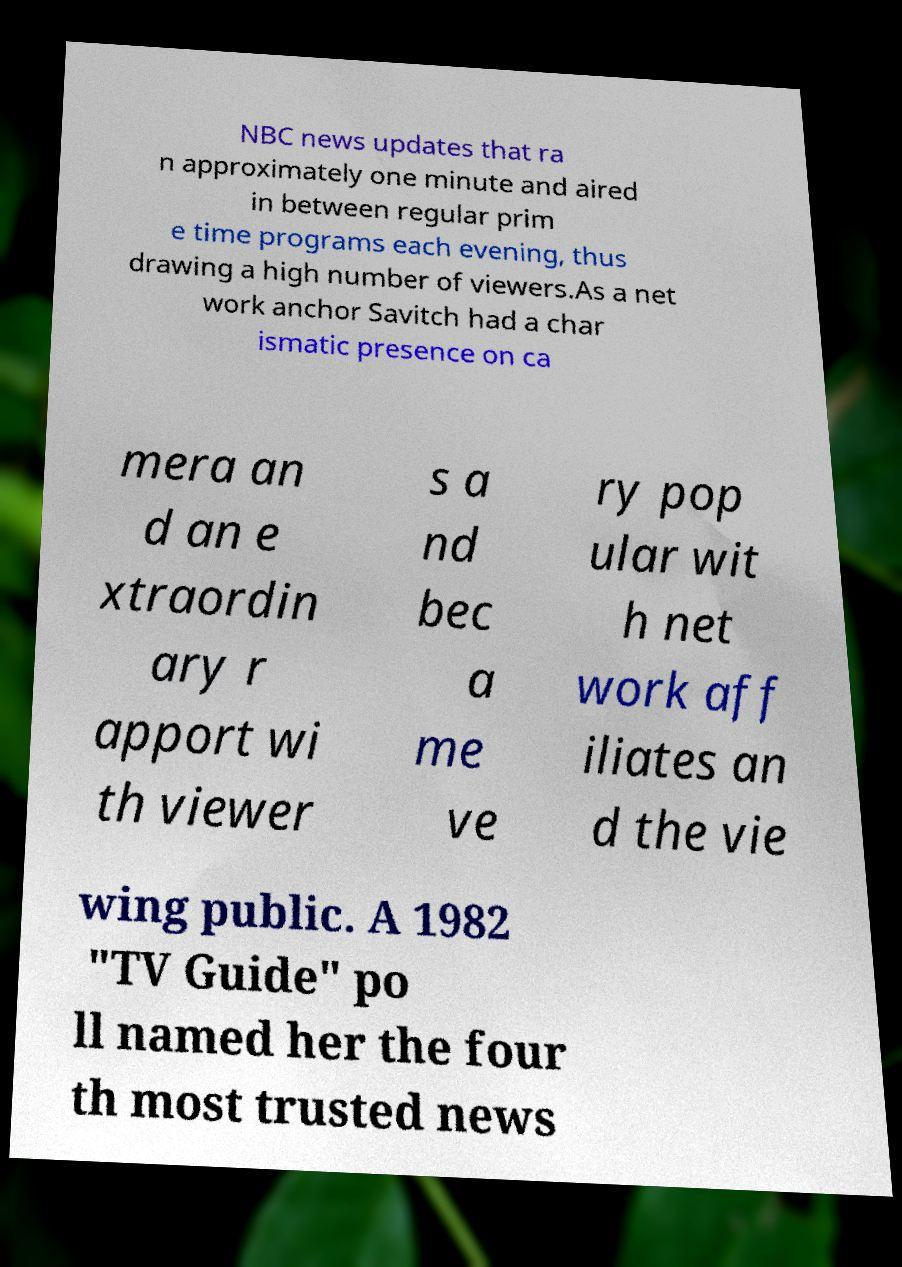There's text embedded in this image that I need extracted. Can you transcribe it verbatim? NBC news updates that ra n approximately one minute and aired in between regular prim e time programs each evening, thus drawing a high number of viewers.As a net work anchor Savitch had a char ismatic presence on ca mera an d an e xtraordin ary r apport wi th viewer s a nd bec a me ve ry pop ular wit h net work aff iliates an d the vie wing public. A 1982 "TV Guide" po ll named her the four th most trusted news 